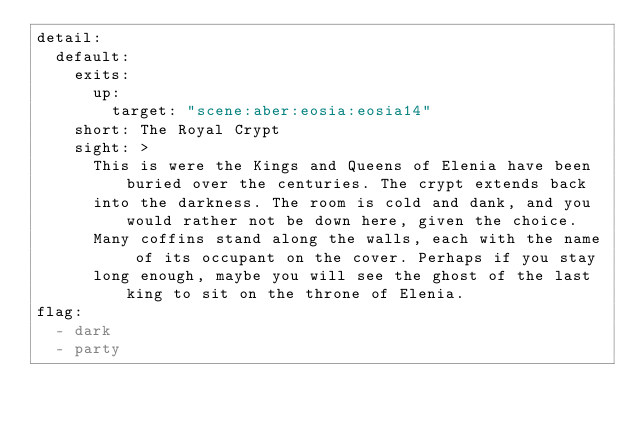<code> <loc_0><loc_0><loc_500><loc_500><_YAML_>detail:
  default:
    exits:
      up:
        target: "scene:aber:eosia:eosia14"
    short: The Royal Crypt
    sight: >
      This is were the Kings and Queens of Elenia have been buried over the centuries. The crypt extends back
      into the darkness. The room is cold and dank, and you would rather not be down here, given the choice.
      Many coffins stand along the walls, each with the name of its occupant on the cover. Perhaps if you stay
      long enough, maybe you will see the ghost of the last king to sit on the throne of Elenia.
flag:
  - dark
  - party
</code> 